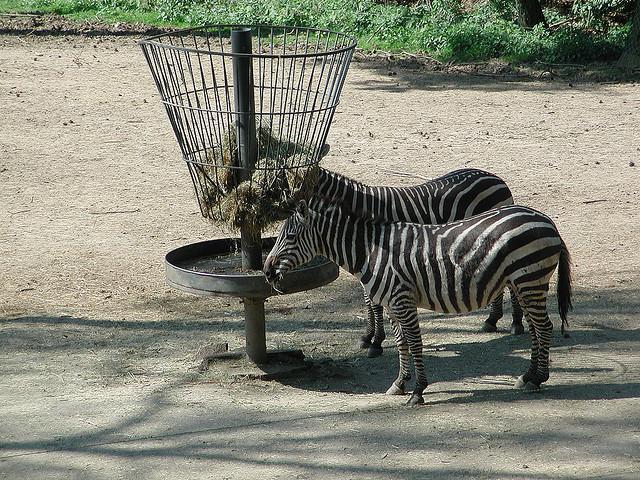How many zebras are in the photo?
Give a very brief answer. 2. How many donuts are on the plate?
Give a very brief answer. 0. 